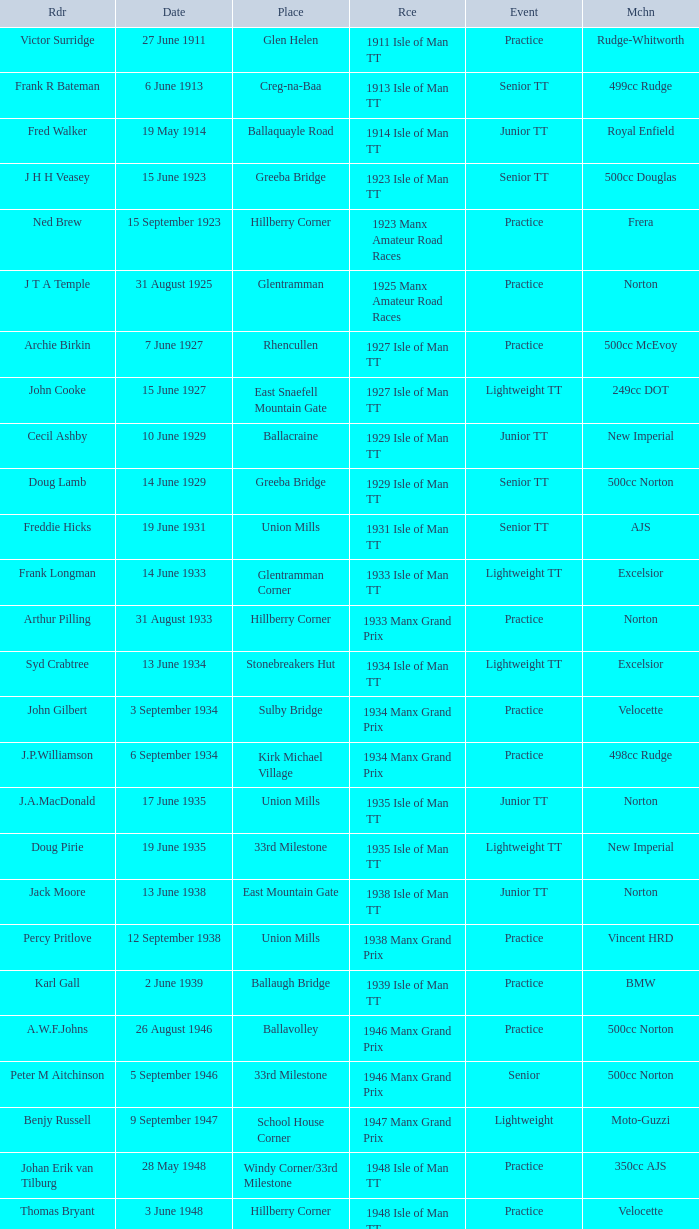Harry l Stephen rides a Norton machine on what date? 8 June 1953. 